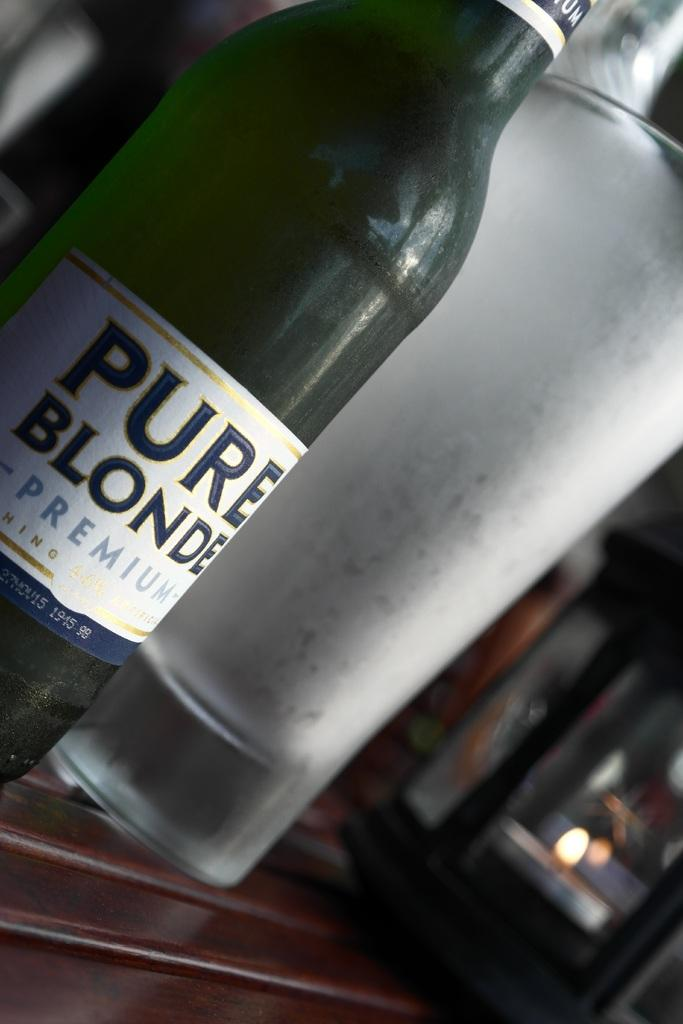<image>
Provide a brief description of the given image. Pure Blonde Premium bottle next to a tall glass cup. 